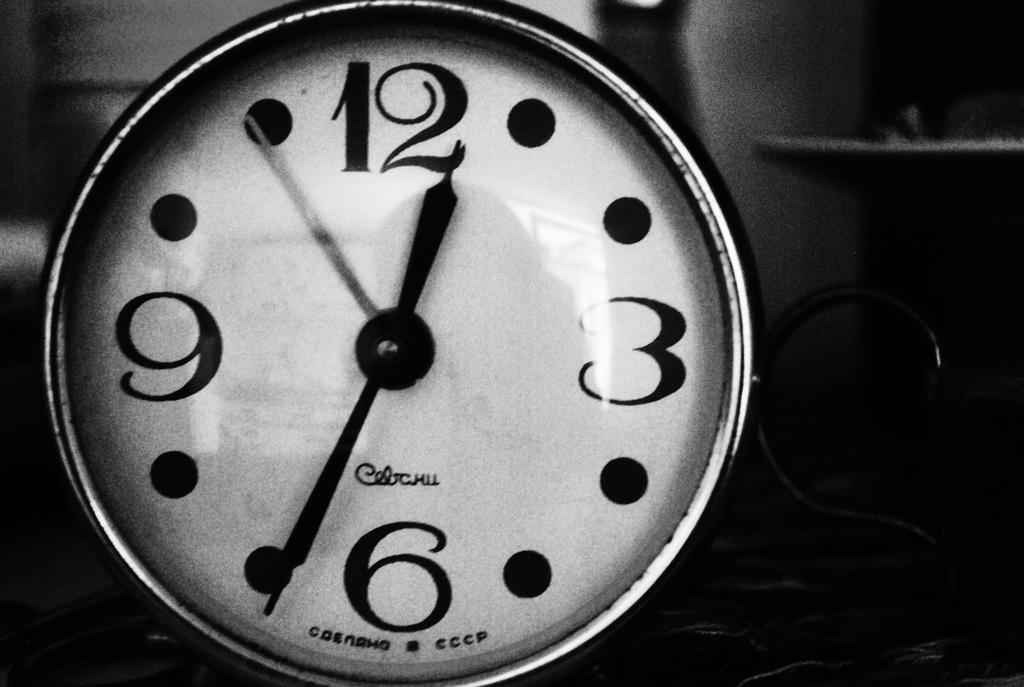<image>
Offer a succinct explanation of the picture presented. A black and white clock face show the time of 12:34. 